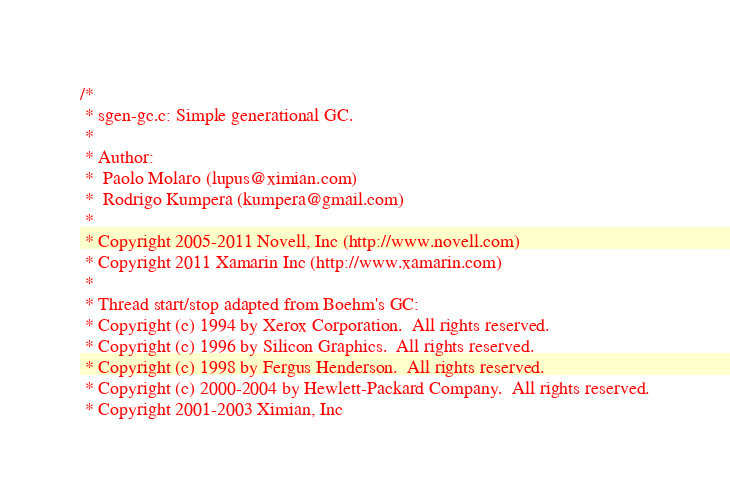<code> <loc_0><loc_0><loc_500><loc_500><_C_>/*
 * sgen-gc.c: Simple generational GC.
 *
 * Author:
 * 	Paolo Molaro (lupus@ximian.com)
 *  Rodrigo Kumpera (kumpera@gmail.com)
 *
 * Copyright 2005-2011 Novell, Inc (http://www.novell.com)
 * Copyright 2011 Xamarin Inc (http://www.xamarin.com)
 *
 * Thread start/stop adapted from Boehm's GC:
 * Copyright (c) 1994 by Xerox Corporation.  All rights reserved.
 * Copyright (c) 1996 by Silicon Graphics.  All rights reserved.
 * Copyright (c) 1998 by Fergus Henderson.  All rights reserved.
 * Copyright (c) 2000-2004 by Hewlett-Packard Company.  All rights reserved.
 * Copyright 2001-2003 Ximian, Inc</code> 